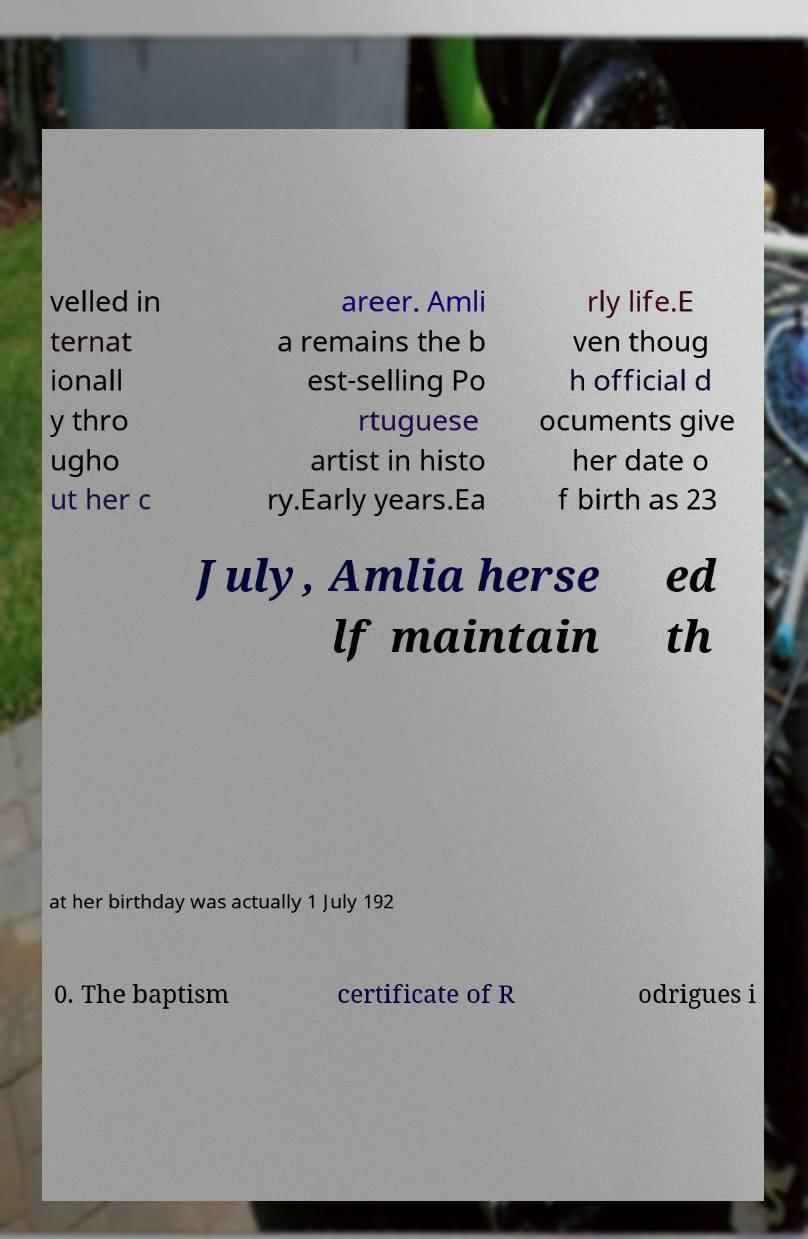What messages or text are displayed in this image? I need them in a readable, typed format. velled in ternat ionall y thro ugho ut her c areer. Amli a remains the b est-selling Po rtuguese artist in histo ry.Early years.Ea rly life.E ven thoug h official d ocuments give her date o f birth as 23 July, Amlia herse lf maintain ed th at her birthday was actually 1 July 192 0. The baptism certificate of R odrigues i 